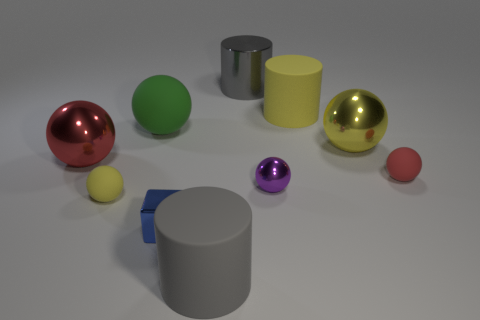There is a green rubber thing that is the same size as the gray matte object; what shape is it? The green object appears to be a sphere, which is a perfectly round geometrical object in three-dimensional space, similar to the shape of a round ball. 